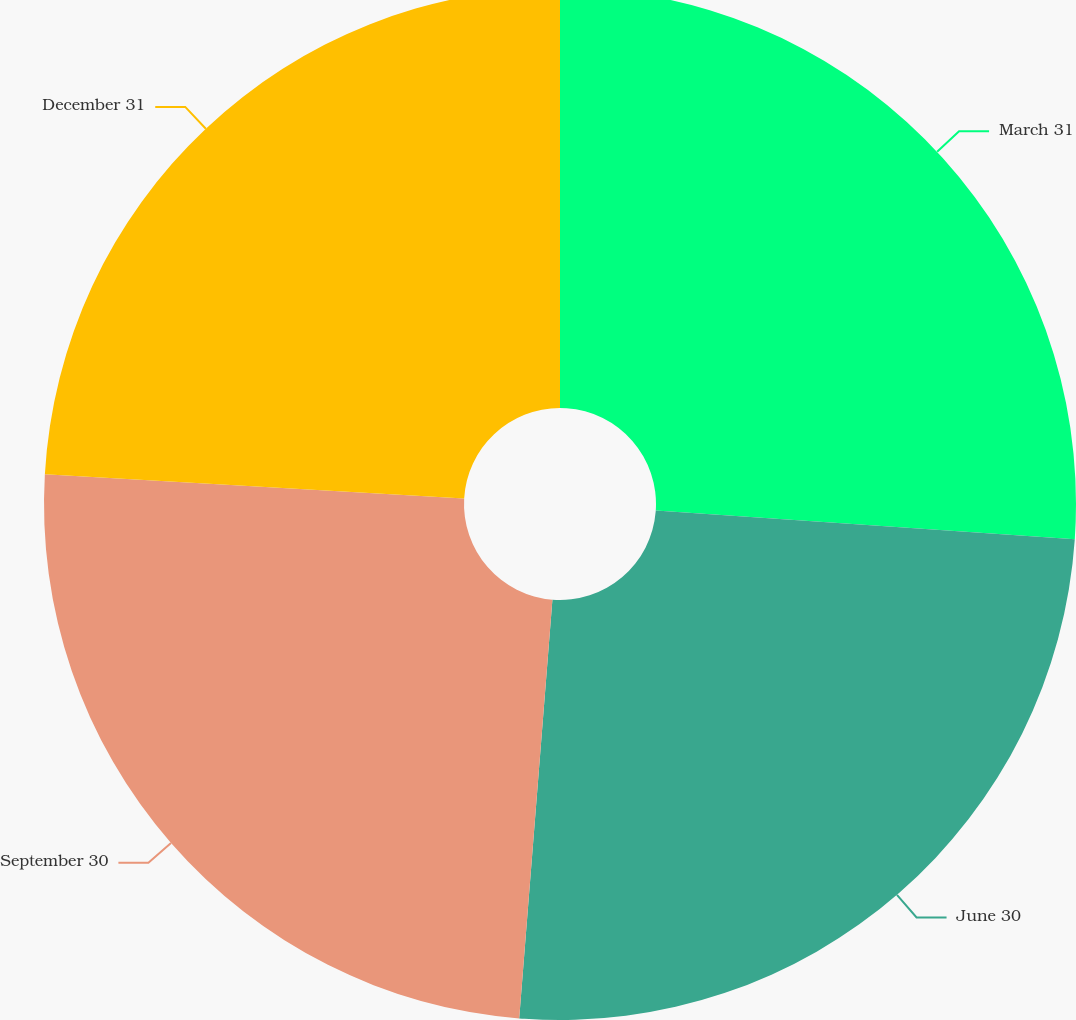Convert chart. <chart><loc_0><loc_0><loc_500><loc_500><pie_chart><fcel>March 31<fcel>June 30<fcel>September 30<fcel>December 31<nl><fcel>26.09%<fcel>25.17%<fcel>24.66%<fcel>24.08%<nl></chart> 